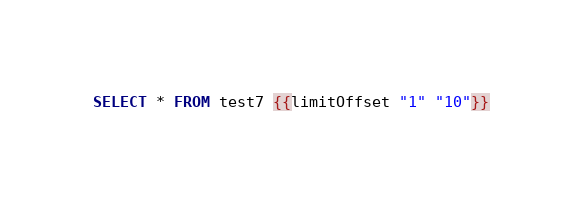Convert code to text. <code><loc_0><loc_0><loc_500><loc_500><_SQL_>SELECT * FROM test7 {{limitOffset "1" "10"}}
</code> 